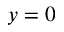Convert formula to latex. <formula><loc_0><loc_0><loc_500><loc_500>y = 0</formula> 